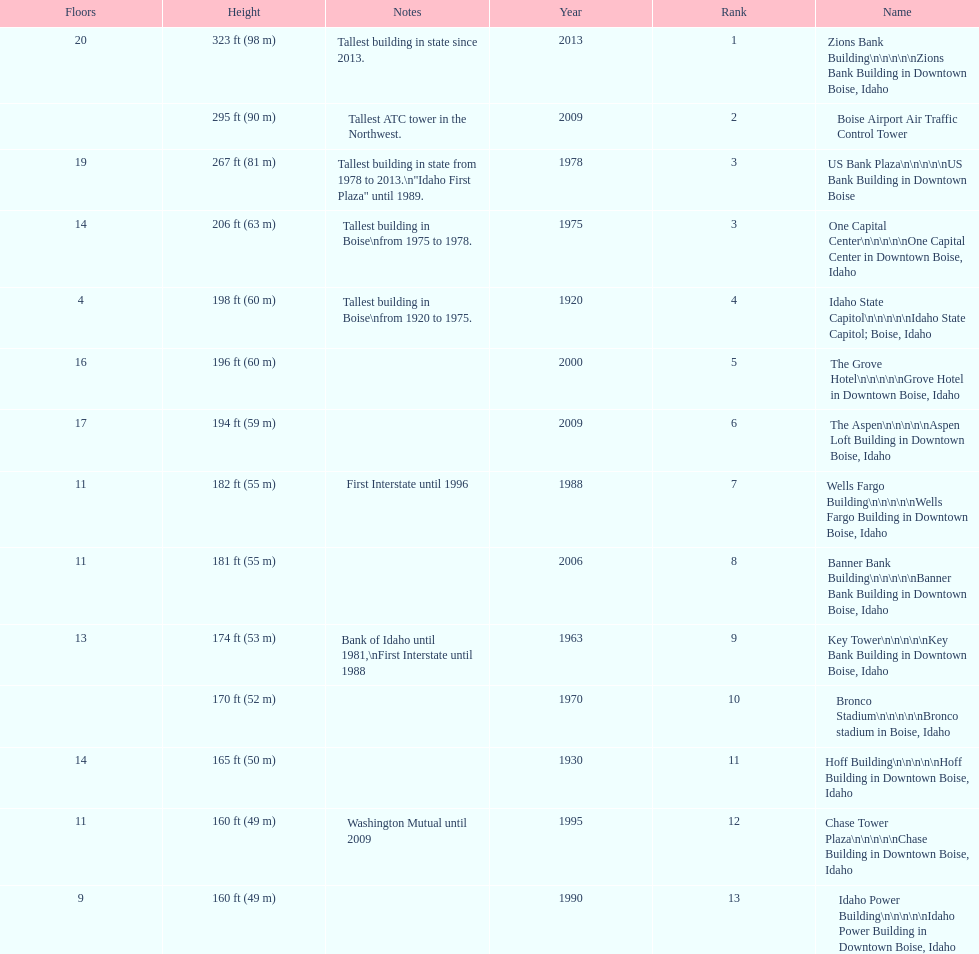How tall (in meters) is the tallest building? 98 m. 